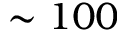Convert formula to latex. <formula><loc_0><loc_0><loc_500><loc_500>\sim 1 0 0</formula> 